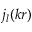Convert formula to latex. <formula><loc_0><loc_0><loc_500><loc_500>j _ { l } ( k r )</formula> 